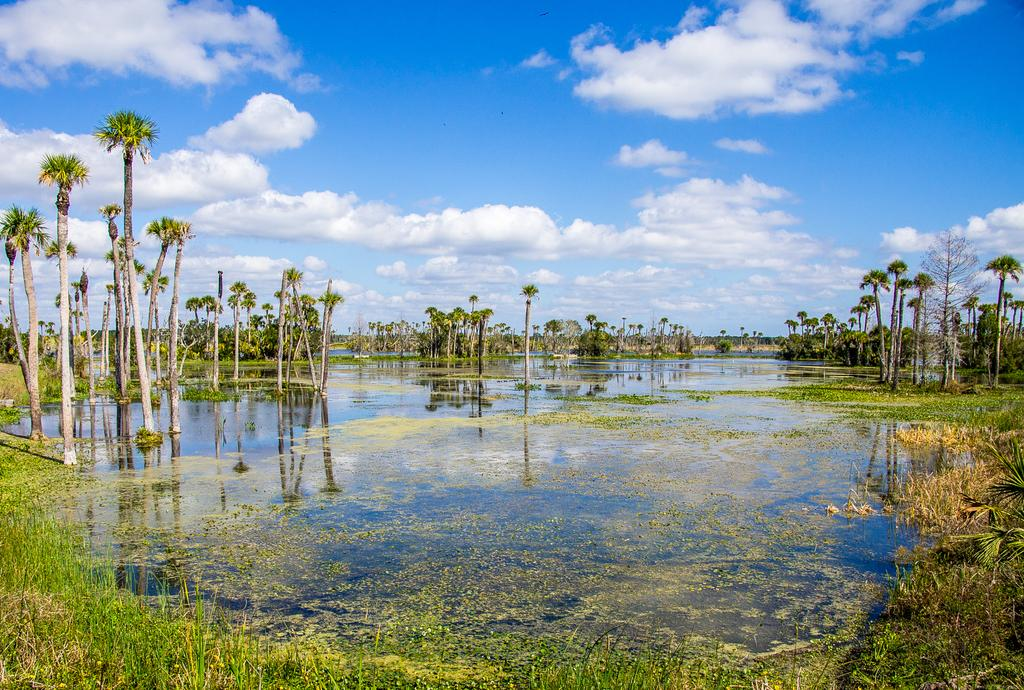What is on the water in the image? There is grass on the water in the image. What is located in the center of the image? There is water in the center of the image. What can be seen in the background of the image? There are trees in the background of the image. How would you describe the sky in the image? The sky is cloudy in the background of the image. What type of soda can be seen floating on the water in the image? There is no soda present in the image; it features grass on the water. What sound can be heard coming from the clouds in the image? There is no sound coming from the clouds in the image, as clouds are silent and do not produce sound. 